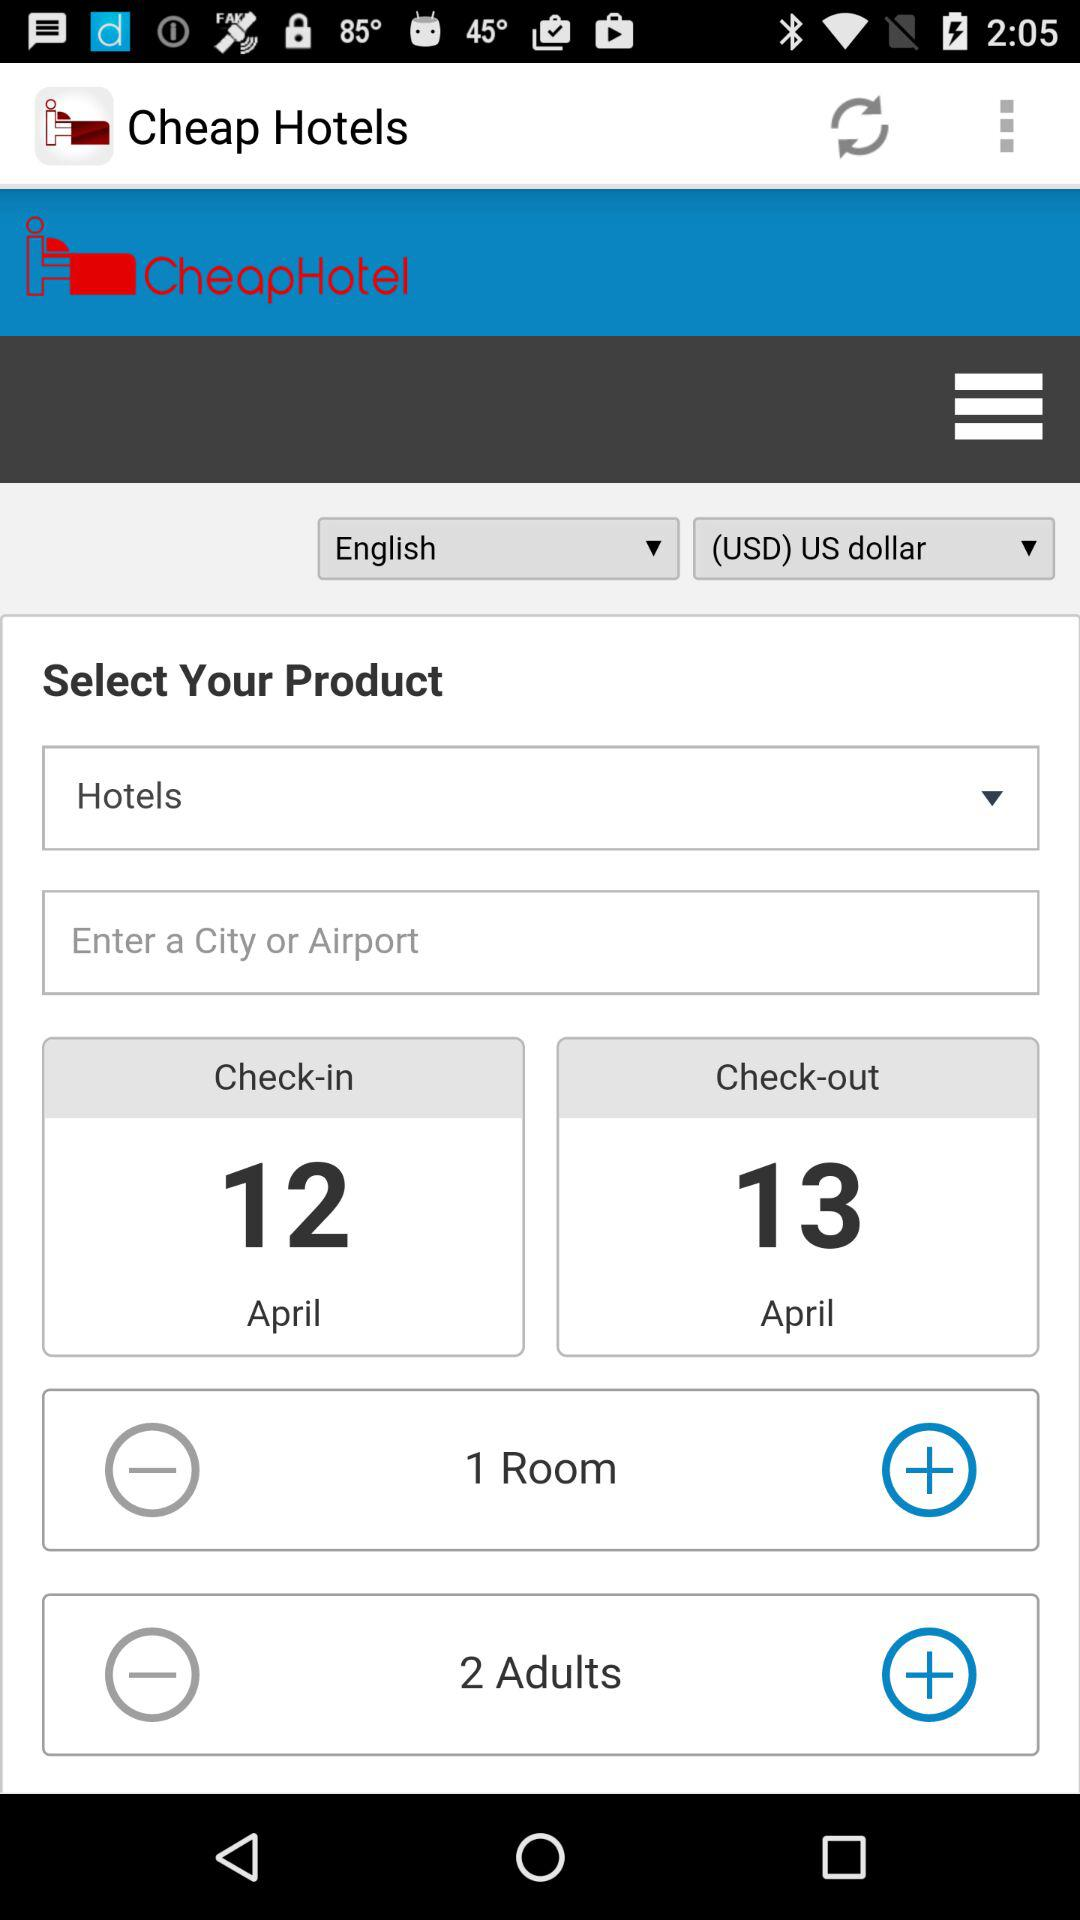When will the check-out be? The check-out will be on April 13. 